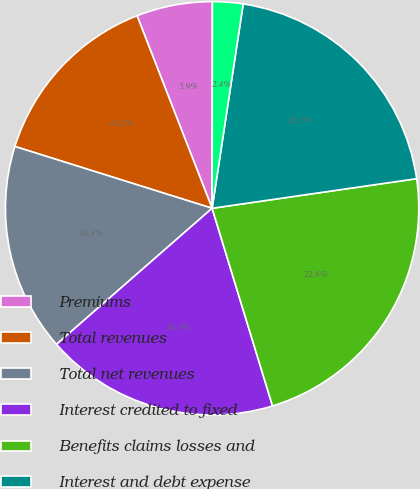<chart> <loc_0><loc_0><loc_500><loc_500><pie_chart><fcel>Premiums<fcel>Total revenues<fcel>Total net revenues<fcel>Interest credited to fixed<fcel>Benefits claims losses and<fcel>Interest and debt expense<fcel>General and administrative<nl><fcel>5.94%<fcel>14.25%<fcel>16.27%<fcel>18.29%<fcel>22.57%<fcel>20.31%<fcel>2.38%<nl></chart> 